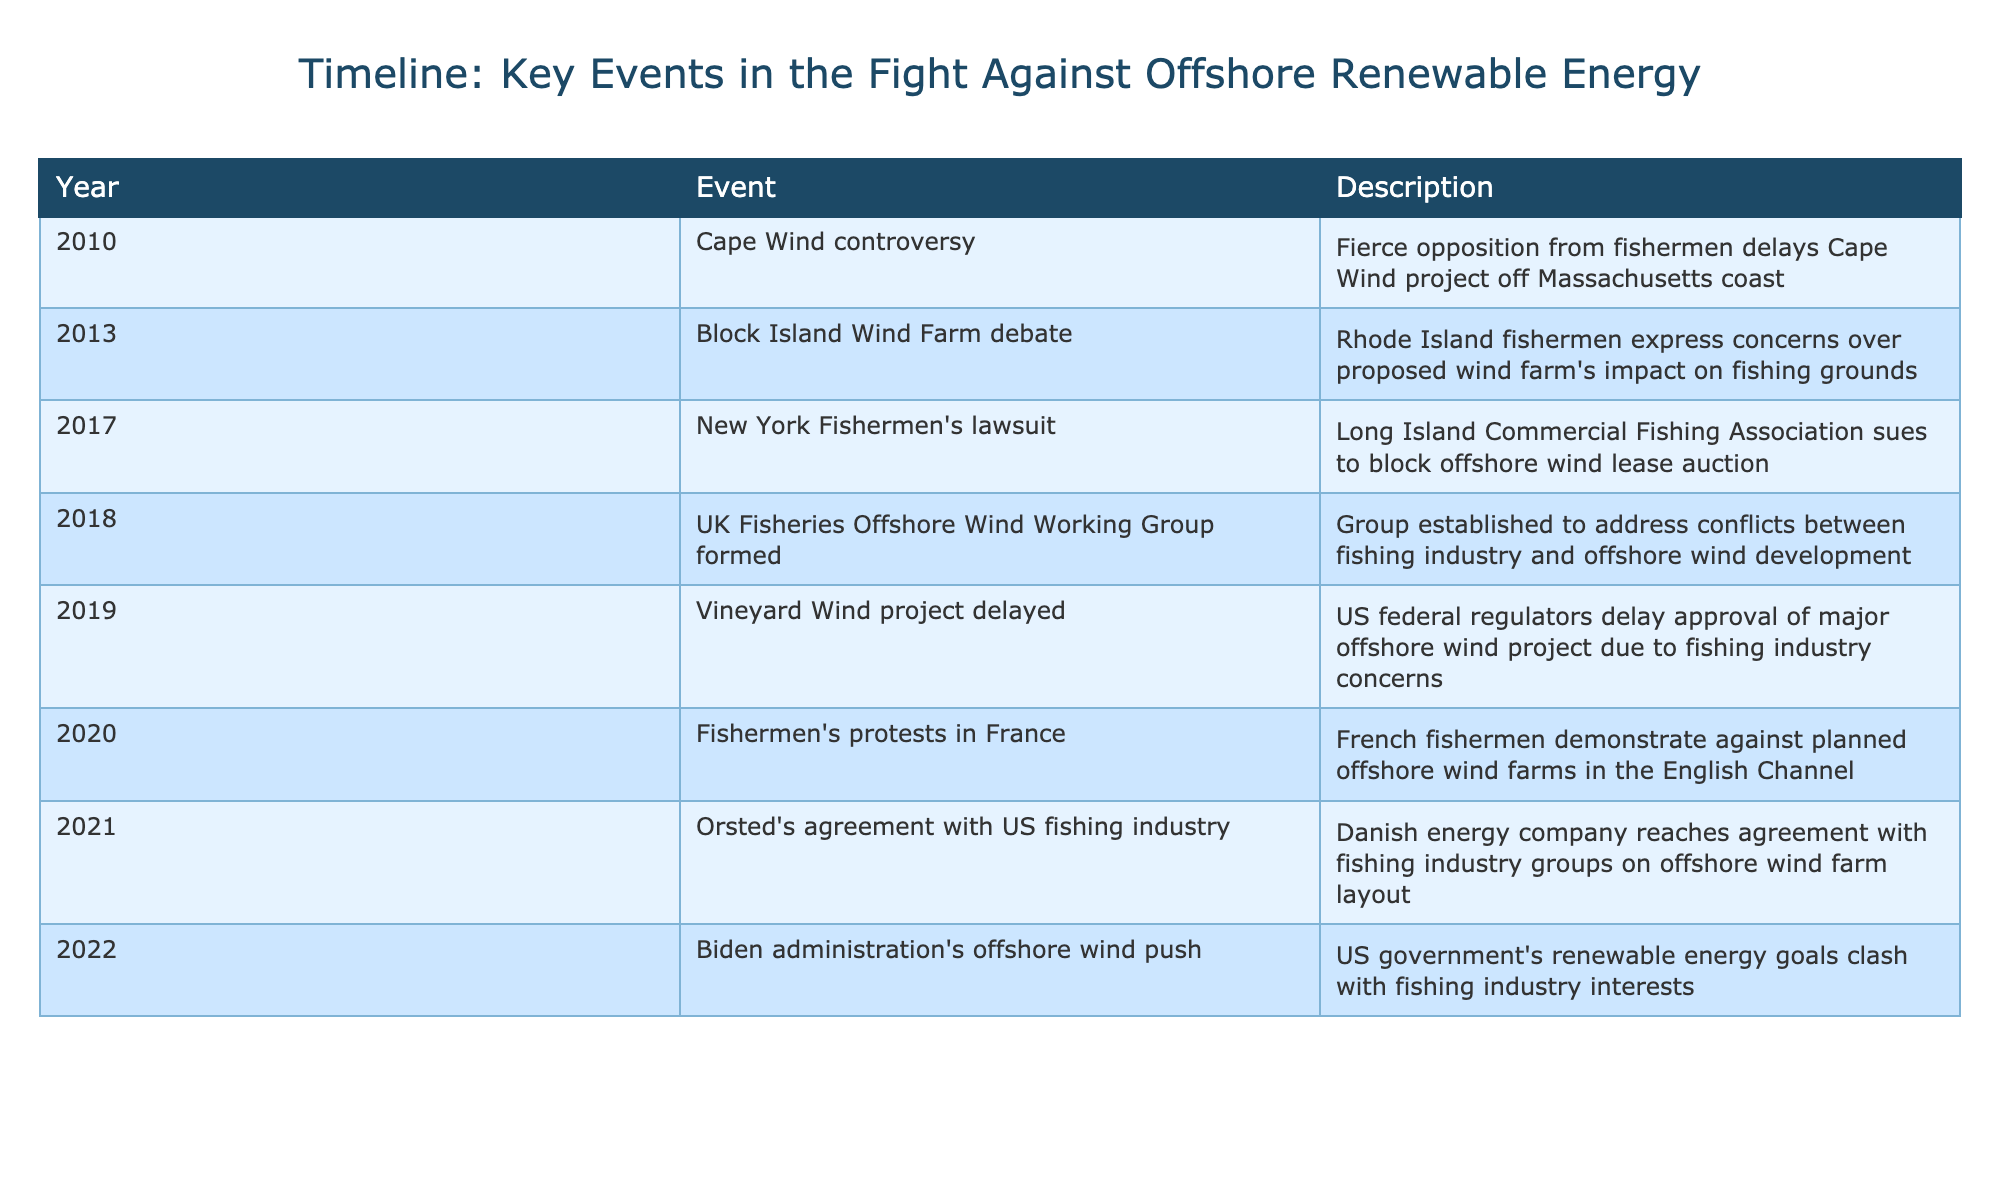What event occurred in 2010? The table shows that in 2010, the Cape Wind controversy generated fierce opposition from fishermen, leading to delays in the project off the Massachusetts coast.
Answer: Cape Wind controversy How many events are listed for the year 2019? The table indicates that there is a single event listed for 2019, which is the delay of the Vineyard Wind project due to fishing industry concerns.
Answer: 1 Which event in 2020 involved protests? According to the table, the event in 2020 that involved protests was the demonstration by French fishermen against planned offshore wind farms in the English Channel.
Answer: Fishermen's protests in France What is the total number of events listed between 2010 and 2022? The table lists a total of 8 events that occurred from 2010 to 2022, including Cape Wind controversy in 2010 and the Biden administration's offshore wind push in 2022.
Answer: 8 Did the UK form a group to address fishing and wind energy conflicts in 2018? Yes, the table confirms that in 2018, the UK Fisheries Offshore Wind Working Group was formed to address conflicts between the fishing industry and offshore wind development.
Answer: Yes What was the outcome of the Long Island Commercial Fishing Association's lawsuit in 2017? The table does not specify the outcome of the lawsuit filed by the Long Island Commercial Fishing Association in 2017 to block the offshore wind lease auction; it only states that the lawsuit was initiated.
Answer: Not specified What significant clash occurred in 2022? The table notes that in 2022, there was a push by the Biden administration towards offshore wind, which clashed with the interests of the fishing industry.
Answer: Biden administration's offshore wind push Which year had two notable events concerning fishermen's concerns? Looking at the table, both 2013 and 2020 had significant events where fishermen expressed concerns: in 2013 regarding the Block Island Wind Farm and in 2020 with protests in France.
Answer: 2013 and 2020 